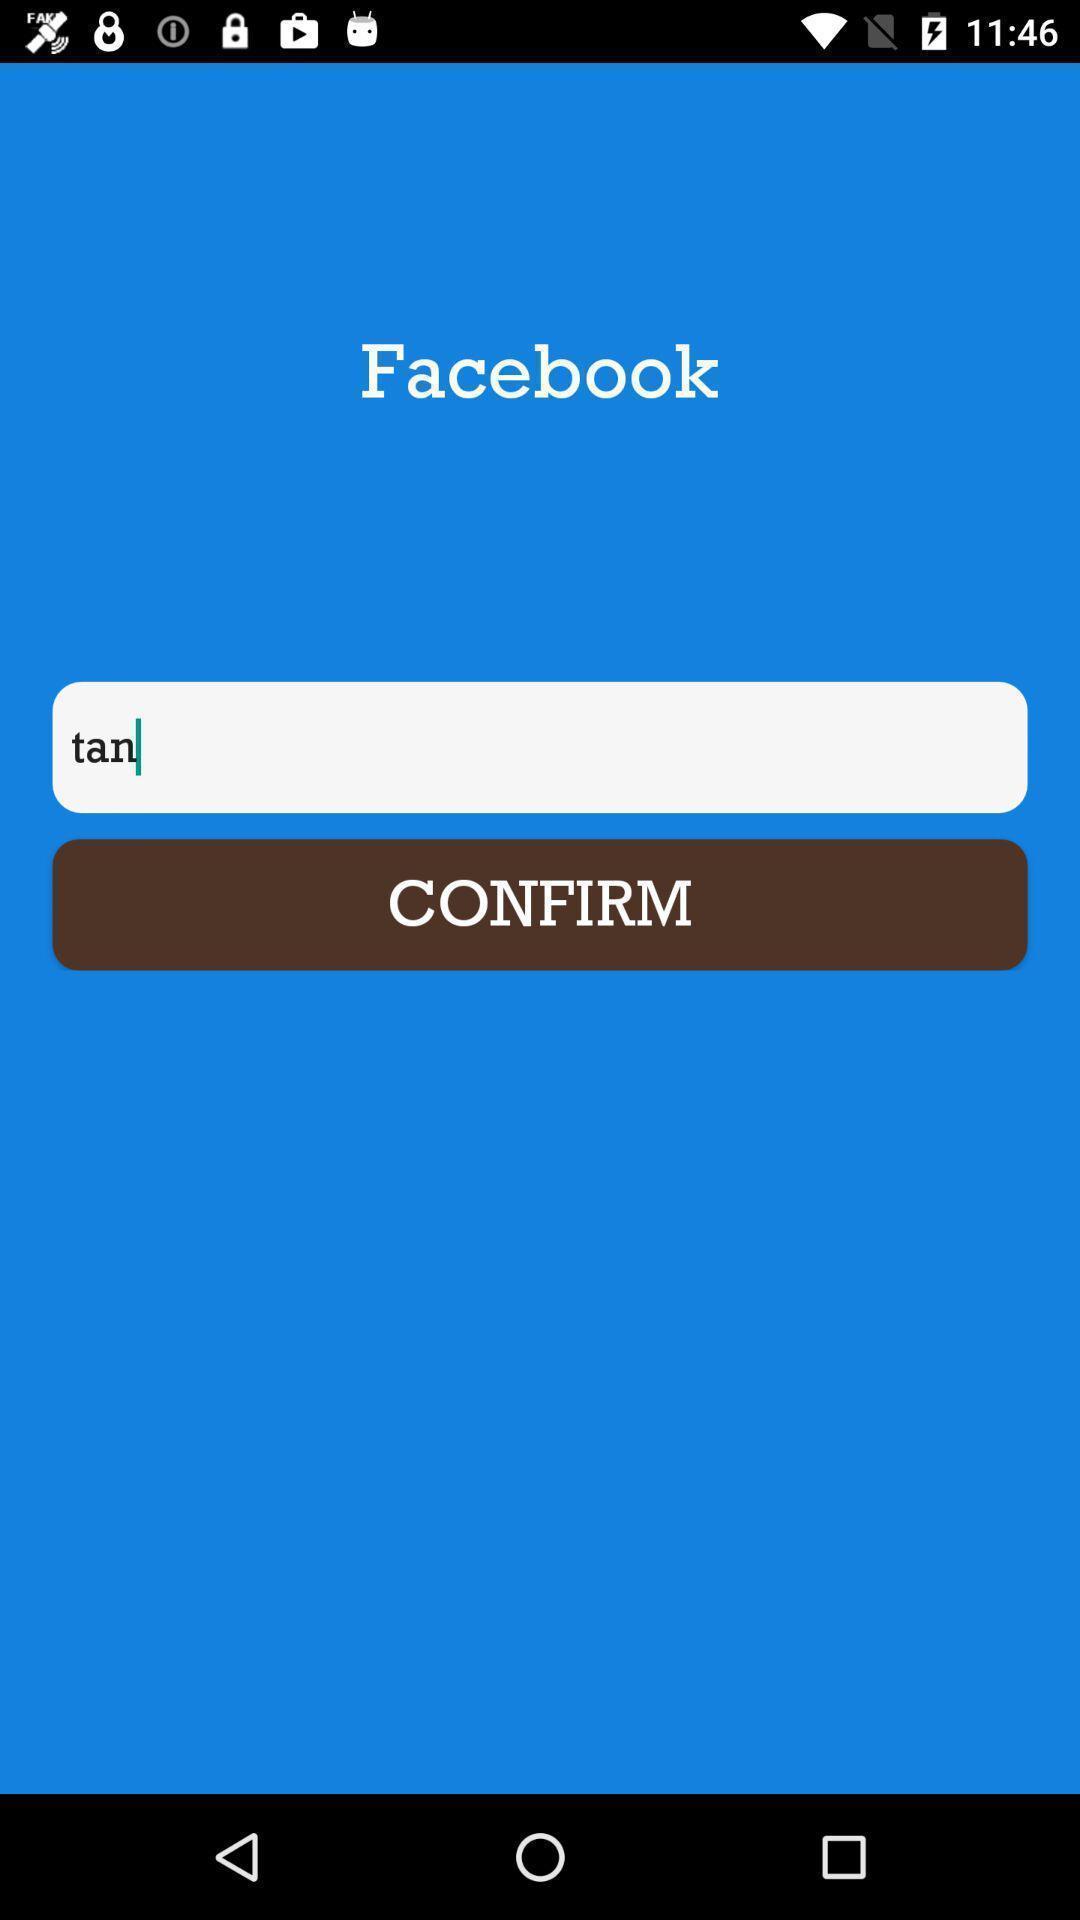Give me a summary of this screen capture. Social app page asking to confirm. 